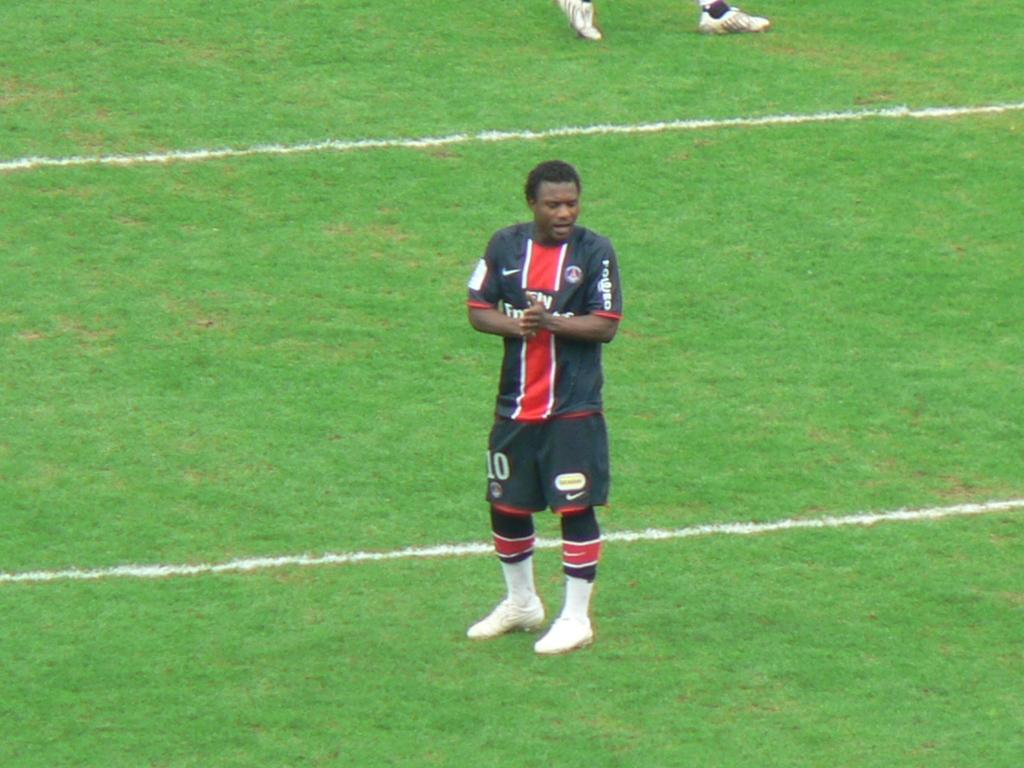What number is the player?
Keep it short and to the point. 10. What company logo is on the left of his jersey?
Provide a succinct answer. Nike. 